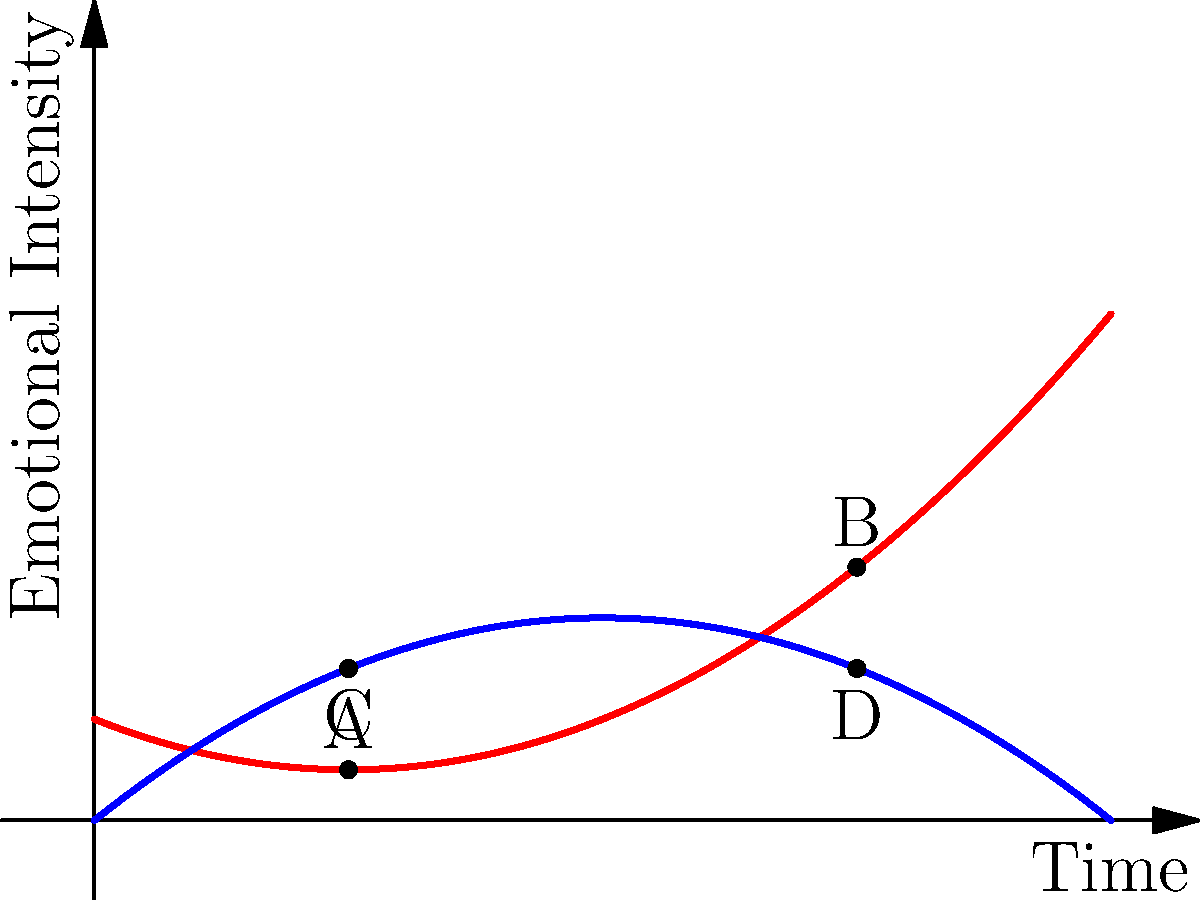As a romance novelist, you're analyzing the emotional arcs in your latest work. The red line represents the protagonist's emotional journey, while the blue line represents that of the love interest. At which point in the story do the characters experience the greatest emotional alignment, and how might this impact the narrative structure? To answer this question, we need to analyze the graph and understand the concept of emotional alignment in romance novels:

1. The x-axis represents time progression in the story, while the y-axis represents emotional intensity.

2. The red line (protagonist) and blue line (love interest) show different emotional arcs throughout the story.

3. Emotional alignment occurs when the two characters' emotions are closest to each other, which graphically translates to the smallest vertical distance between the two lines.

4. To find the point of greatest alignment:
   a) At x = 0, the gap is relatively large.
   b) At x = 1 (point A and C), the gap has decreased.
   c) At x = 2, the lines intersect, indicating perfect alignment.
   d) After x = 2, the lines begin to diverge again.

5. The point of intersection at x = 2 represents the moment of greatest emotional alignment between the characters.

6. In terms of narrative structure, this point of alignment often coincides with a pivotal moment in the story, such as:
   - A shared experience or challenge
   - A mutual understanding or revelation
   - A turning point in their relationship

7. This alignment can serve as a catalyst for further plot development, potentially leading to:
   - Increased intimacy between characters
   - A shift in the dynamic of their relationship
   - New conflicts or obstacles to overcome

By positioning this moment of alignment strategically in the story, a romance novelist can create a powerful emotional resonance for readers and drive the narrative forward.
Answer: The point of intersection at x = 2, representing the greatest emotional alignment, likely serves as a pivotal moment in the story's structure. 